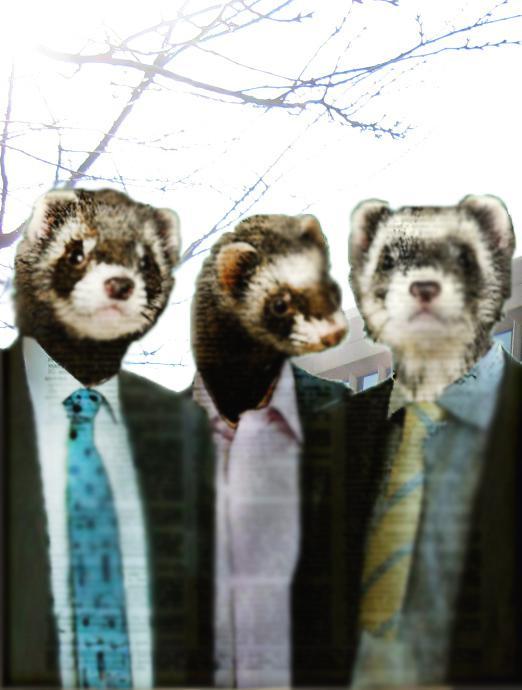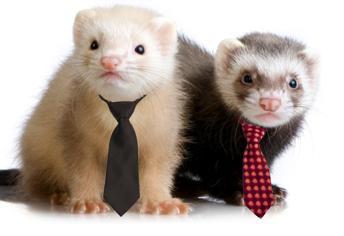The first image is the image on the left, the second image is the image on the right. Given the left and right images, does the statement "Three prairie dogs are poking their heads out of the ground in one of the images." hold true? Answer yes or no. No. 